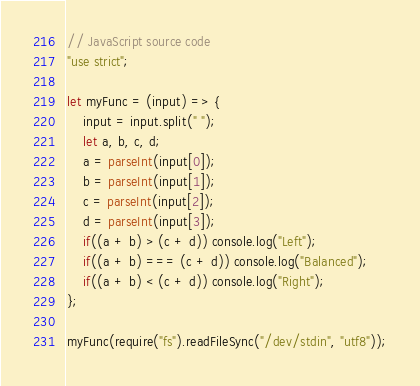<code> <loc_0><loc_0><loc_500><loc_500><_JavaScript_>// JavaScript source code
"use strict";

let myFunc = (input) => {
    input = input.split(" ");
    let a, b, c, d;
    a = parseInt(input[0]);
    b = parseInt(input[1]);
    c = parseInt(input[2]);
    d = parseInt(input[3]);
    if((a + b) > (c + d)) console.log("Left");
    if((a + b) === (c + d)) console.log("Balanced");
    if((a + b) < (c + d)) console.log("Right");
};

myFunc(require("fs").readFileSync("/dev/stdin", "utf8"));</code> 